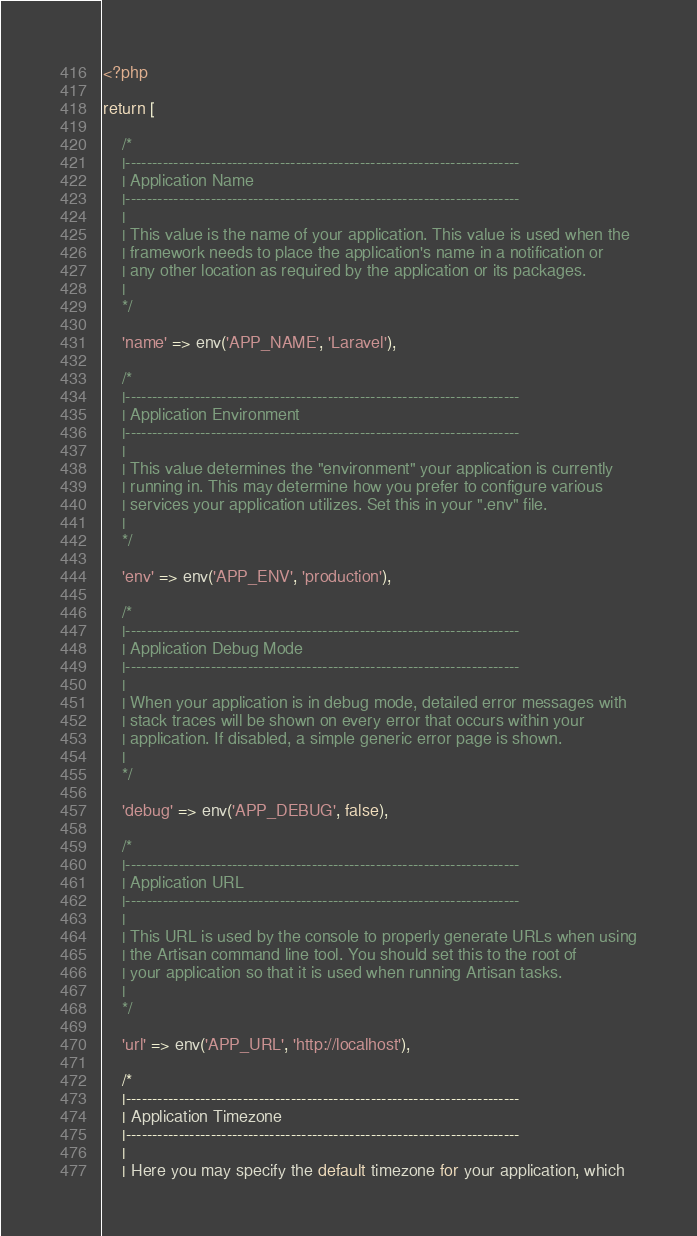<code> <loc_0><loc_0><loc_500><loc_500><_PHP_><?php

return [

    /*
    |--------------------------------------------------------------------------
    | Application Name
    |--------------------------------------------------------------------------
    |
    | This value is the name of your application. This value is used when the
    | framework needs to place the application's name in a notification or
    | any other location as required by the application or its packages.
    |
    */

    'name' => env('APP_NAME', 'Laravel'),

    /*
    |--------------------------------------------------------------------------
    | Application Environment
    |--------------------------------------------------------------------------
    |
    | This value determines the "environment" your application is currently
    | running in. This may determine how you prefer to configure various
    | services your application utilizes. Set this in your ".env" file.
    |
    */

    'env' => env('APP_ENV', 'production'),

    /*
    |--------------------------------------------------------------------------
    | Application Debug Mode
    |--------------------------------------------------------------------------
    |
    | When your application is in debug mode, detailed error messages with
    | stack traces will be shown on every error that occurs within your
    | application. If disabled, a simple generic error page is shown.
    |
    */

    'debug' => env('APP_DEBUG', false),

    /*
    |--------------------------------------------------------------------------
    | Application URL
    |--------------------------------------------------------------------------
    |
    | This URL is used by the console to properly generate URLs when using
    | the Artisan command line tool. You should set this to the root of
    | your application so that it is used when running Artisan tasks.
    |
    */

    'url' => env('APP_URL', 'http://localhost'),

    /*
    |--------------------------------------------------------------------------
    | Application Timezone
    |--------------------------------------------------------------------------
    |
    | Here you may specify the default timezone for your application, which</code> 